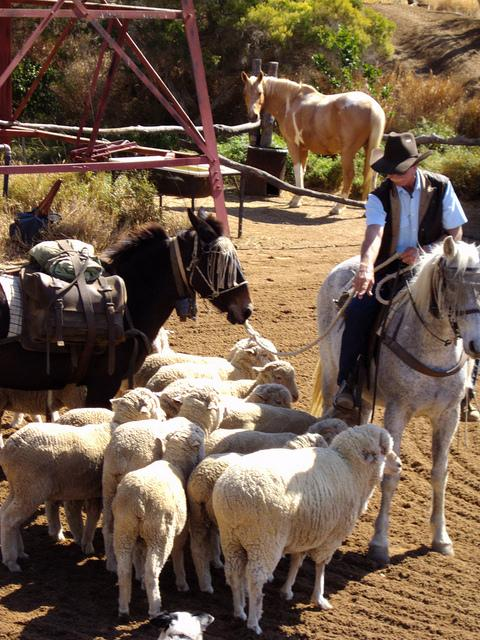What other animal could help here?

Choices:
A) snakes
B) bees
C) cats
D) dogs dogs 